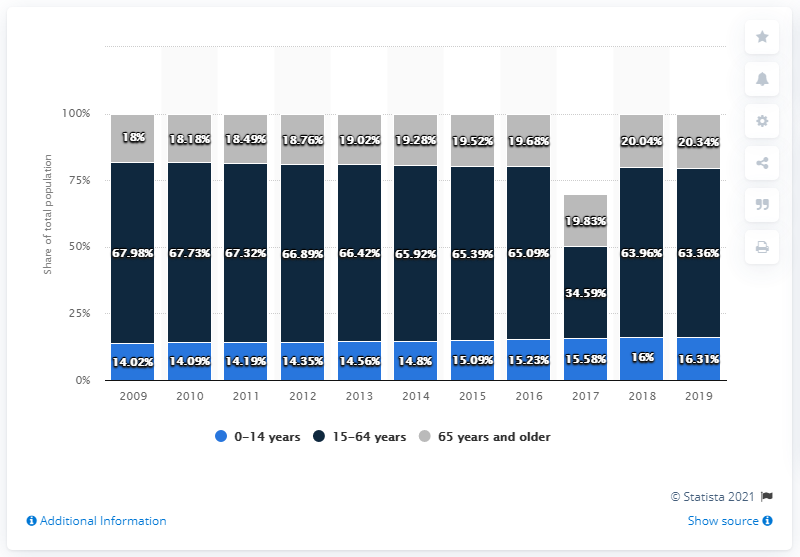Give some essential details in this illustration. The mode value for the age range of 0-14 years is approximately 0. The year with the least number of incidents in the 15-64 age group is 2017. 